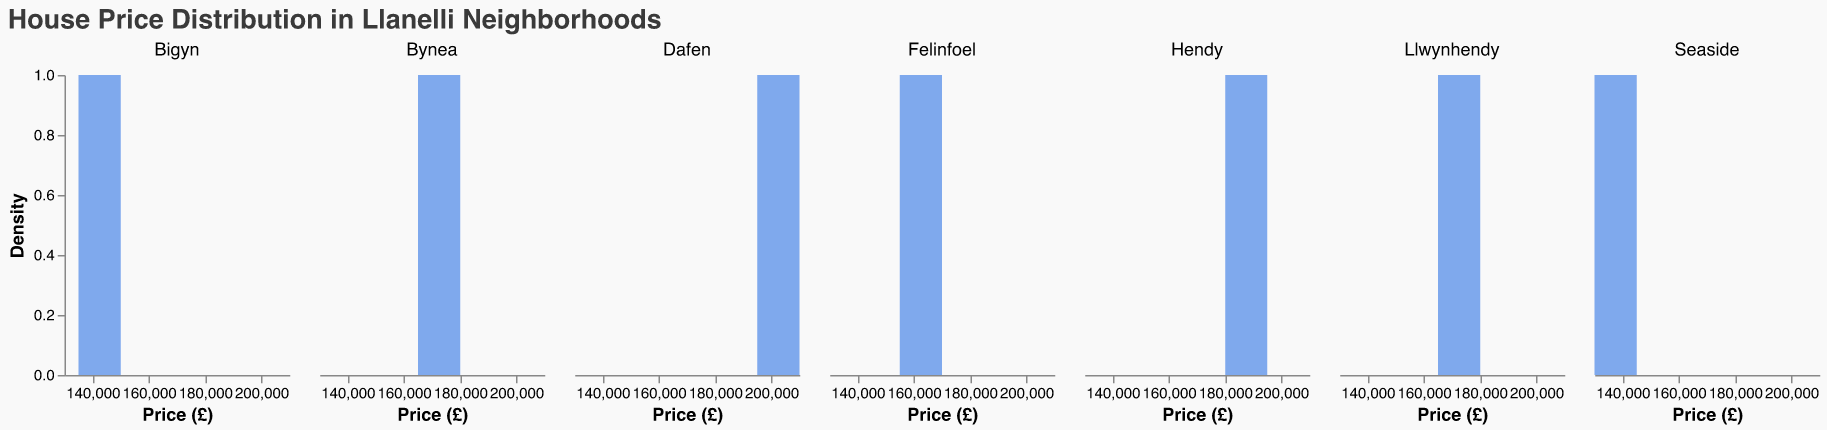What's the title of the figure? The title is displayed at the top of the figure and provides a general description of what the data is about. In this case, it reads "House Price Distribution in Llanelli Neighborhoods."
Answer: House Price Distribution in Llanelli Neighborhoods Which neighborhood has the widest range of house prices? By examining the width of the density plots along the x-axis, the neighborhood with the widest price range can be identified. Dafen has a wider spread ranging from £195,000 to £210,000.
Answer: Dafen What is the typical house price range for Bynea? Looking at the x-axis values for the Bynea subplot, house prices range from about £165,000 to £180,000.
Answer: £165,000 to £180,000 Which neighborhood appears to have the highest house prices? The highest house prices can be identified by looking at the neighborhoods where the density plots are farthest to the right. Dafen's prices range from £195,000 to £210,000, which is the highest range among the neighborhoods.
Answer: Dafen Compare the price range of Bigyn and Seaside. The x-axis values for Bigyn range from £135,000 to £150,000, while Seaside ranges from £130,000 to £145,000. Comparing these ranges shows that Bigyn has a slightly higher upper bound.
Answer: Bigyn: £135,000 to £150,000, Seaside: £130,000 to £145,000 What neighborhood has the most similar price range to Llwynhendy? Llwynhendy's price range is from £165,000 to £180,000. Felinfoel shares a similar price range of £155,000 to £170,000, making them closely aligned.
Answer: Felinfoel How many neighborhoods have house prices ranging from £130,000 to £150,000? By inspecting the x-axis ranges of all subplots, both Bigyn and Seaside fall within the £130,000 to £150,000 range.
Answer: 2 neighborhoods (Bigyn and Seaside) What is the distribution shape of house prices in Hendy? The shape of the density plot can be observed. Hendy's plot shows a roughly symmetric, bell-shaped distribution centered around £185,000 to £190,000.
Answer: Bell-shaped In which neighborhood is the house price distribution the most skewed? The shape's skewness is identified by observing the plot's asymmetry. Dafen shows a plot stretching more towards higher prices, indicating right skewness.
Answer: Dafen What does the y-axis represent in these subplots? The y-axis in the figure measures density, indicating how house prices are distributed within each neighborhood.
Answer: Density 